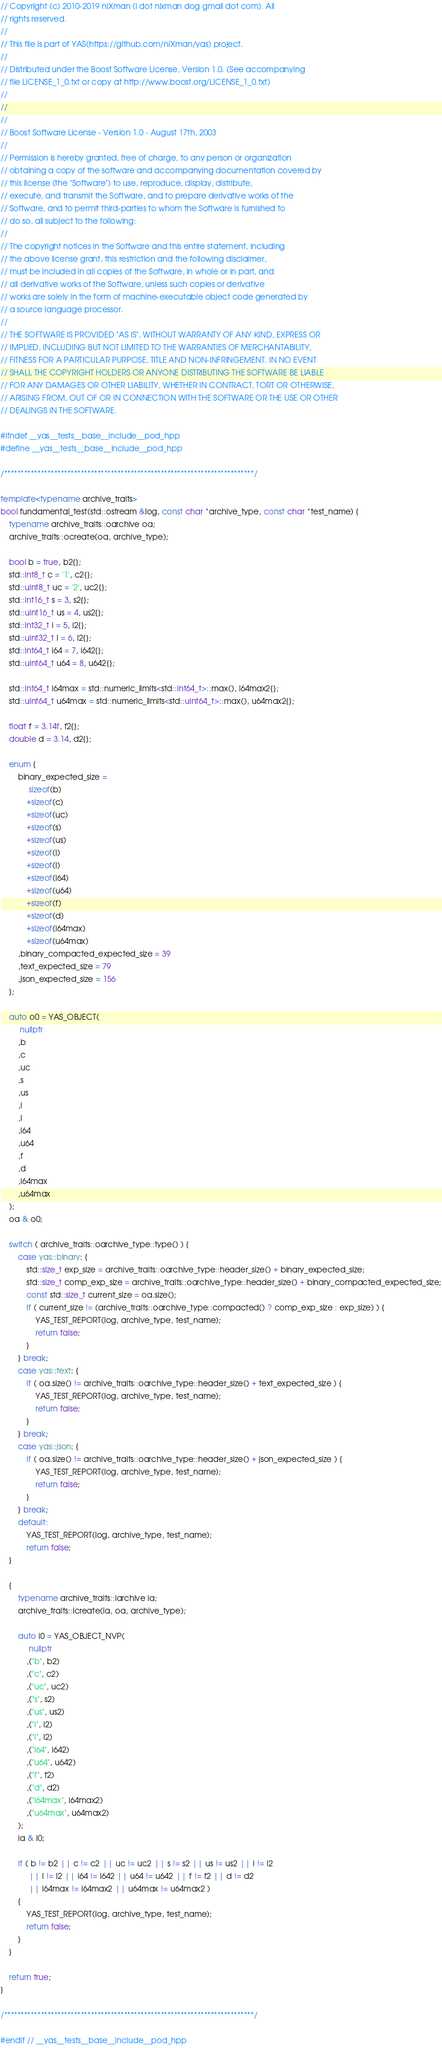Convert code to text. <code><loc_0><loc_0><loc_500><loc_500><_C++_>
// Copyright (c) 2010-2019 niXman (i dot nixman dog gmail dot com). All
// rights reserved.
//
// This file is part of YAS(https://github.com/niXman/yas) project.
//
// Distributed under the Boost Software License, Version 1.0. (See accompanying
// file LICENSE_1_0.txt or copy at http://www.boost.org/LICENSE_1_0.txt)
//
//
//
// Boost Software License - Version 1.0 - August 17th, 2003
//
// Permission is hereby granted, free of charge, to any person or organization
// obtaining a copy of the software and accompanying documentation covered by
// this license (the "Software") to use, reproduce, display, distribute,
// execute, and transmit the Software, and to prepare derivative works of the
// Software, and to permit third-parties to whom the Software is furnished to
// do so, all subject to the following:
//
// The copyright notices in the Software and this entire statement, including
// the above license grant, this restriction and the following disclaimer,
// must be included in all copies of the Software, in whole or in part, and
// all derivative works of the Software, unless such copies or derivative
// works are solely in the form of machine-executable object code generated by
// a source language processor.
//
// THE SOFTWARE IS PROVIDED "AS IS", WITHOUT WARRANTY OF ANY KIND, EXPRESS OR
// IMPLIED, INCLUDING BUT NOT LIMITED TO THE WARRANTIES OF MERCHANTABILITY,
// FITNESS FOR A PARTICULAR PURPOSE, TITLE AND NON-INFRINGEMENT. IN NO EVENT
// SHALL THE COPYRIGHT HOLDERS OR ANYONE DISTRIBUTING THE SOFTWARE BE LIABLE
// FOR ANY DAMAGES OR OTHER LIABILITY, WHETHER IN CONTRACT, TORT OR OTHERWISE,
// ARISING FROM, OUT OF OR IN CONNECTION WITH THE SOFTWARE OR THE USE OR OTHER
// DEALINGS IN THE SOFTWARE.

#ifndef __yas__tests__base__include__pod_hpp
#define __yas__tests__base__include__pod_hpp

/***************************************************************************/

template<typename archive_traits>
bool fundamental_test(std::ostream &log, const char *archive_type, const char *test_name) {
    typename archive_traits::oarchive oa;
    archive_traits::ocreate(oa, archive_type);

    bool b = true, b2{};
    std::int8_t c = '1', c2{};
    std::uint8_t uc = '2', uc2{};
    std::int16_t s = 3, s2{};
    std::uint16_t us = 4, us2{};
    std::int32_t i = 5, i2{};
    std::uint32_t l = 6, l2{};
    std::int64_t i64 = 7, i642{};
    std::uint64_t u64 = 8, u642{};

    std::int64_t i64max = std::numeric_limits<std::int64_t>::max(), i64max2{};
    std::uint64_t u64max = std::numeric_limits<std::uint64_t>::max(), u64max2{};

    float f = 3.14f, f2{};
    double d = 3.14, d2{};

    enum {
        binary_expected_size =
             sizeof(b)
            +sizeof(c)
            +sizeof(uc)
            +sizeof(s)
            +sizeof(us)
            +sizeof(i)
            +sizeof(l)
            +sizeof(i64)
            +sizeof(u64)
            +sizeof(f)
            +sizeof(d)
            +sizeof(i64max)
            +sizeof(u64max)
        ,binary_compacted_expected_size = 39
        ,text_expected_size = 79
        ,json_expected_size = 156
    };

    auto o0 = YAS_OBJECT(
         nullptr
        ,b
        ,c
        ,uc
        ,s
        ,us
        ,i
        ,l
        ,i64
        ,u64
        ,f
        ,d
        ,i64max
        ,u64max
    );
    oa & o0;

    switch ( archive_traits::oarchive_type::type() ) {
        case yas::binary: {
            std::size_t exp_size = archive_traits::oarchive_type::header_size() + binary_expected_size;
            std::size_t comp_exp_size = archive_traits::oarchive_type::header_size() + binary_compacted_expected_size;
            const std::size_t current_size = oa.size();
            if ( current_size != (archive_traits::oarchive_type::compacted() ? comp_exp_size : exp_size) ) {
                YAS_TEST_REPORT(log, archive_type, test_name);
                return false;
            }
        } break;
        case yas::text: {
            if ( oa.size() != archive_traits::oarchive_type::header_size() + text_expected_size ) {
                YAS_TEST_REPORT(log, archive_type, test_name);
                return false;
            }
        } break;
        case yas::json: {
            if ( oa.size() != archive_traits::oarchive_type::header_size() + json_expected_size ) {
                YAS_TEST_REPORT(log, archive_type, test_name);
                return false;
            }
        } break;
        default:
            YAS_TEST_REPORT(log, archive_type, test_name);
            return false;
    }

    {
        typename archive_traits::iarchive ia;
        archive_traits::icreate(ia, oa, archive_type);

        auto i0 = YAS_OBJECT_NVP(
             nullptr
            ,("b", b2)
            ,("c", c2)
            ,("uc", uc2)
            ,("s", s2)
            ,("us", us2)
            ,("i", i2)
            ,("l", l2)
            ,("i64", i642)
            ,("u64", u642)
            ,("f", f2)
            ,("d", d2)
            ,("i64max", i64max2)
            ,("u64max", u64max2)
        );
        ia & i0;

        if ( b != b2 || c != c2 || uc != uc2 || s != s2 || us != us2 || i != i2
             || l != l2 || i64 != i642 || u64 != u642 || f != f2 || d != d2
             || i64max != i64max2 || u64max != u64max2 )
        {
            YAS_TEST_REPORT(log, archive_type, test_name);
            return false;
        }
    }

    return true;
}

/***************************************************************************/

#endif // __yas__tests__base__include__pod_hpp
</code> 